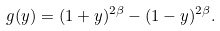<formula> <loc_0><loc_0><loc_500><loc_500>g ( y ) = ( 1 + y ) ^ { 2 \beta } - ( 1 - y ) ^ { 2 \beta } .</formula> 